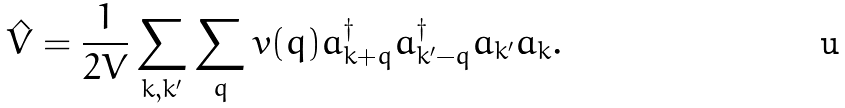Convert formula to latex. <formula><loc_0><loc_0><loc_500><loc_500>\hat { V } = \frac { 1 } { 2 V } \sum _ { k , k ^ { \prime } } \sum _ { q } v ( { q } ) a _ { k + q } ^ { \dagger } a _ { k ^ { \prime } - q } ^ { \dagger } a _ { k ^ { \prime } } a _ { k } .</formula> 